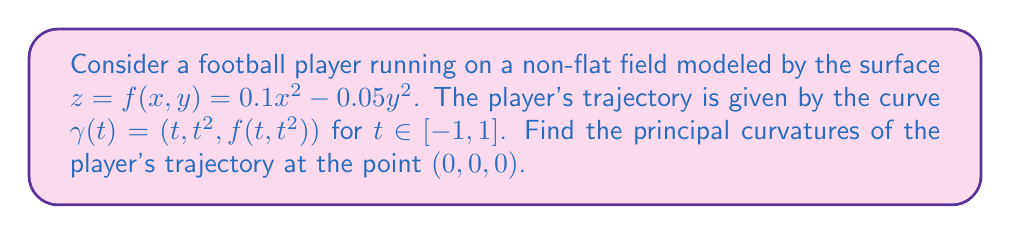Provide a solution to this math problem. To find the principal curvatures, we need to follow these steps:

1) First, we need to calculate the first and second fundamental forms of the surface.

2) The first fundamental form coefficients are:
   $$E = 1 + (f_x)^2, \quad F = f_x f_y, \quad G = 1 + (f_y)^2$$
   where $f_x = 0.2x$ and $f_y = -0.1y$

3) The second fundamental form coefficients are:
   $$L = \frac{f_{xx}}{\sqrt{1+f_x^2+f_y^2}}, \quad M = \frac{f_{xy}}{\sqrt{1+f_x^2+f_y^2}}, \quad N = \frac{f_{yy}}{\sqrt{1+f_x^2+f_y^2}}$$
   where $f_{xx} = 0.2$, $f_{xy} = 0$, and $f_{yy} = -0.1$

4) At the point (0,0,0), we have:
   $$E = 1, \quad F = 0, \quad G = 1$$
   $$L = 0.2, \quad M = 0, \quad N = -0.1$$

5) The principal curvatures are the eigenvalues of the shape operator, which can be found by solving:
   $$\det(S - \kappa I) = 0$$
   where $S$ is the shape operator matrix:
   $$S = \begin{pmatrix} L & M \\ M & N \end{pmatrix} = \begin{pmatrix} 0.2 & 0 \\ 0 & -0.1 \end{pmatrix}$$

6) Solving the characteristic equation:
   $$\det\begin{pmatrix} 0.2 - \kappa & 0 \\ 0 & -0.1 - \kappa \end{pmatrix} = 0$$
   $$(0.2 - \kappa)(-0.1 - \kappa) = 0$$

7) The solutions to this equation are the principal curvatures:
   $$\kappa_1 = 0.2, \quad \kappa_2 = -0.1$$

Therefore, the principal curvatures at the point (0,0,0) are 0.2 and -0.1.
Answer: $\kappa_1 = 0.2, \kappa_2 = -0.1$ 